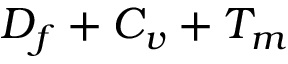<formula> <loc_0><loc_0><loc_500><loc_500>D _ { f } + C _ { v } + T _ { m }</formula> 